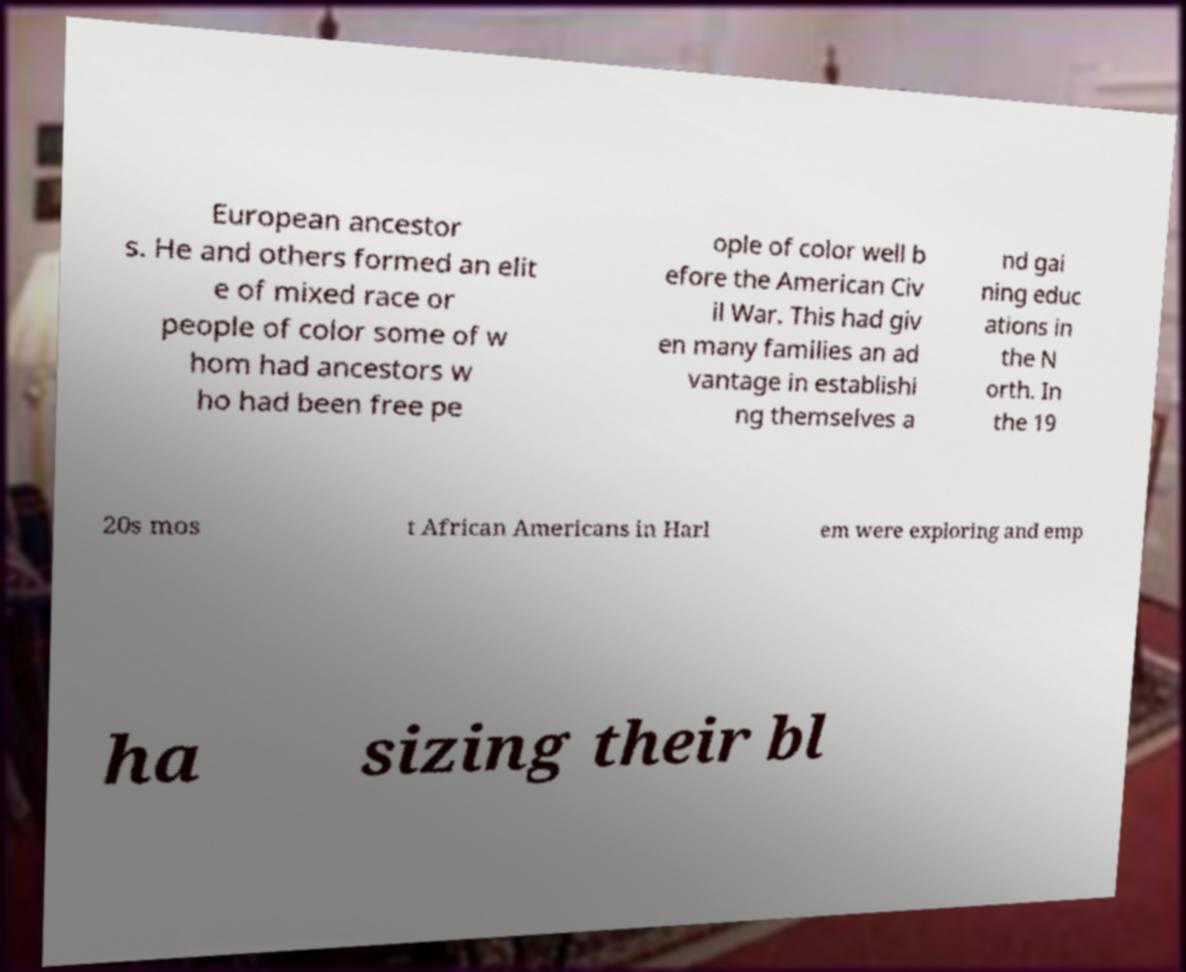Please read and relay the text visible in this image. What does it say? European ancestor s. He and others formed an elit e of mixed race or people of color some of w hom had ancestors w ho had been free pe ople of color well b efore the American Civ il War. This had giv en many families an ad vantage in establishi ng themselves a nd gai ning educ ations in the N orth. In the 19 20s mos t African Americans in Harl em were exploring and emp ha sizing their bl 